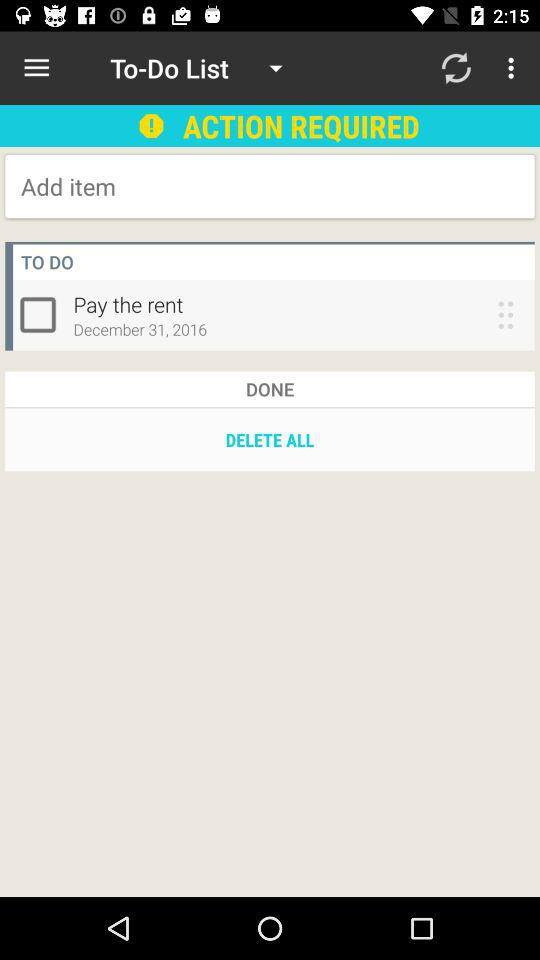What is the date of the task?
Answer the question using a single word or phrase. December 31, 2016 